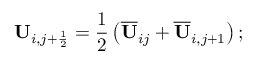<formula> <loc_0><loc_0><loc_500><loc_500>U _ { i , j + \frac { 1 } { 2 } } = \frac { 1 } { 2 } \left ( \overline { U } _ { i j } + \overline { U } _ { i , j + 1 } \right ) ;</formula> 